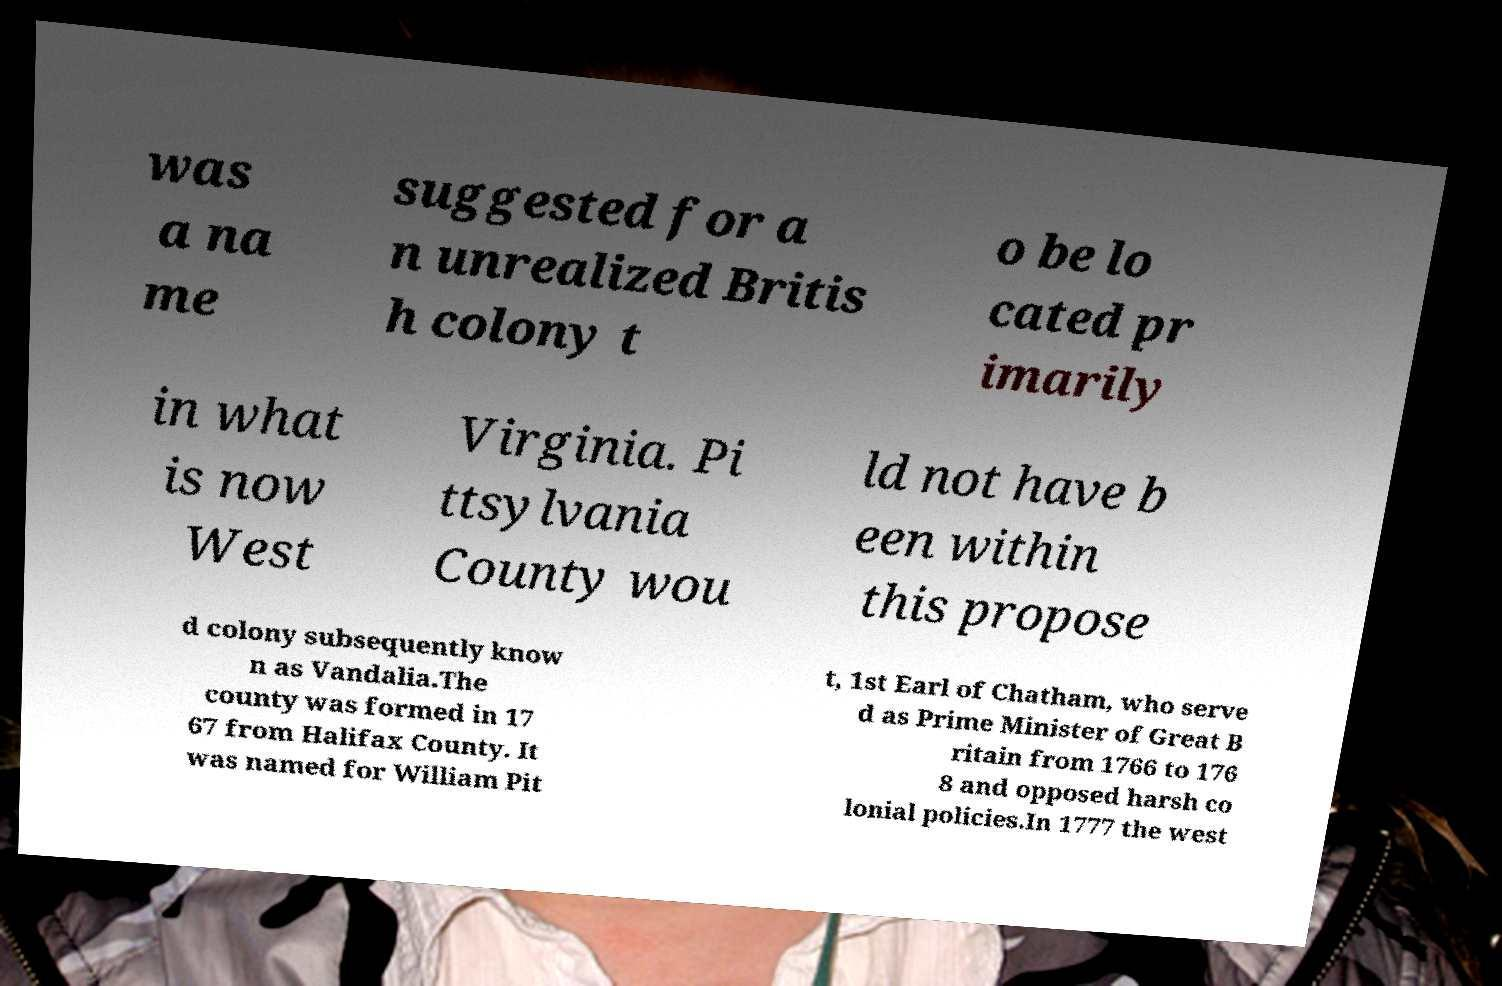Could you assist in decoding the text presented in this image and type it out clearly? was a na me suggested for a n unrealized Britis h colony t o be lo cated pr imarily in what is now West Virginia. Pi ttsylvania County wou ld not have b een within this propose d colony subsequently know n as Vandalia.The county was formed in 17 67 from Halifax County. It was named for William Pit t, 1st Earl of Chatham, who serve d as Prime Minister of Great B ritain from 1766 to 176 8 and opposed harsh co lonial policies.In 1777 the west 